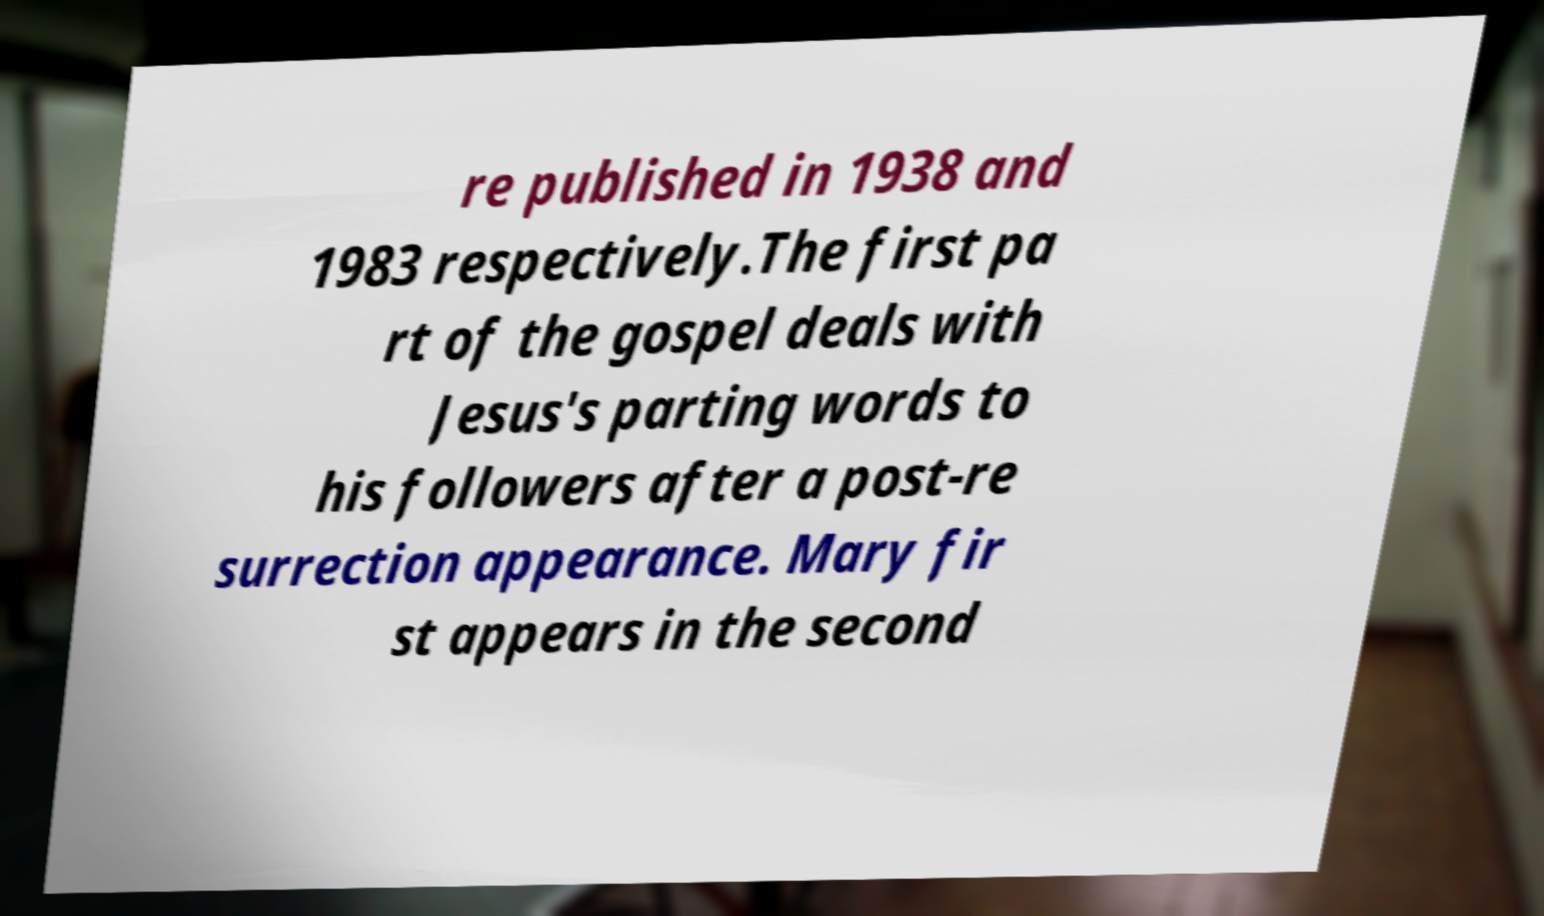Please read and relay the text visible in this image. What does it say? re published in 1938 and 1983 respectively.The first pa rt of the gospel deals with Jesus's parting words to his followers after a post-re surrection appearance. Mary fir st appears in the second 